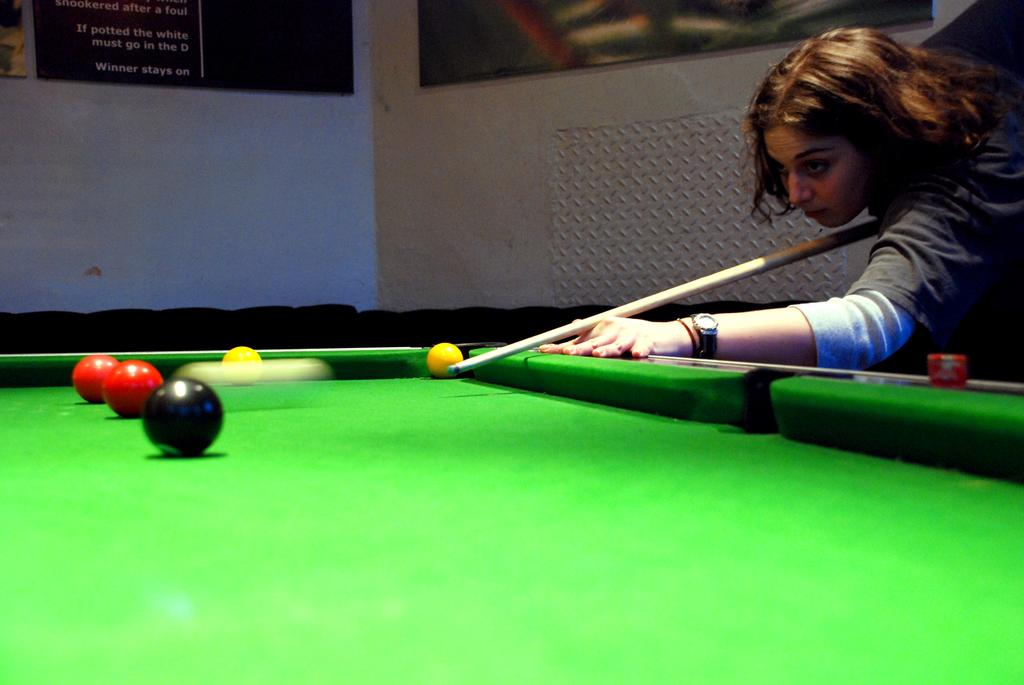Who is the main subject in the image? There is a woman in the image. What is the woman holding in her hands? The woman is holding a stick in her hands. What activity is the woman engaged in? The woman is playing the billiards game. What type of orange can be seen on the cushion in the image? There is no orange or cushion present in the image; the woman is playing billiards with a stick and a billiards table. 